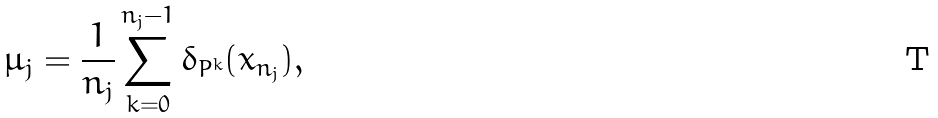<formula> <loc_0><loc_0><loc_500><loc_500>\mu _ { j } = \frac { 1 } { n _ { j } } \sum _ { k = 0 } ^ { n _ { j } - 1 } \delta _ { P ^ { k } } ( x _ { n _ { j } } ) ,</formula> 